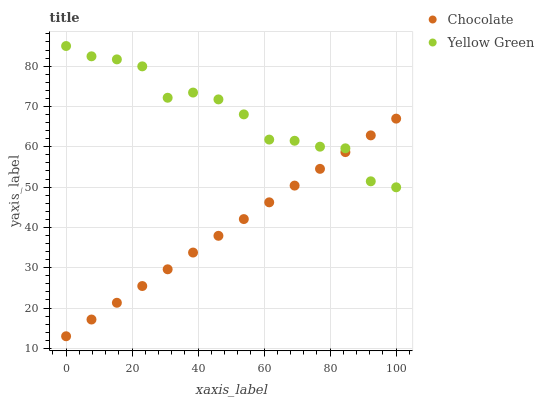Does Chocolate have the minimum area under the curve?
Answer yes or no. Yes. Does Yellow Green have the maximum area under the curve?
Answer yes or no. Yes. Does Chocolate have the maximum area under the curve?
Answer yes or no. No. Is Chocolate the smoothest?
Answer yes or no. Yes. Is Yellow Green the roughest?
Answer yes or no. Yes. Is Chocolate the roughest?
Answer yes or no. No. Does Chocolate have the lowest value?
Answer yes or no. Yes. Does Yellow Green have the highest value?
Answer yes or no. Yes. Does Chocolate have the highest value?
Answer yes or no. No. Does Chocolate intersect Yellow Green?
Answer yes or no. Yes. Is Chocolate less than Yellow Green?
Answer yes or no. No. Is Chocolate greater than Yellow Green?
Answer yes or no. No. 